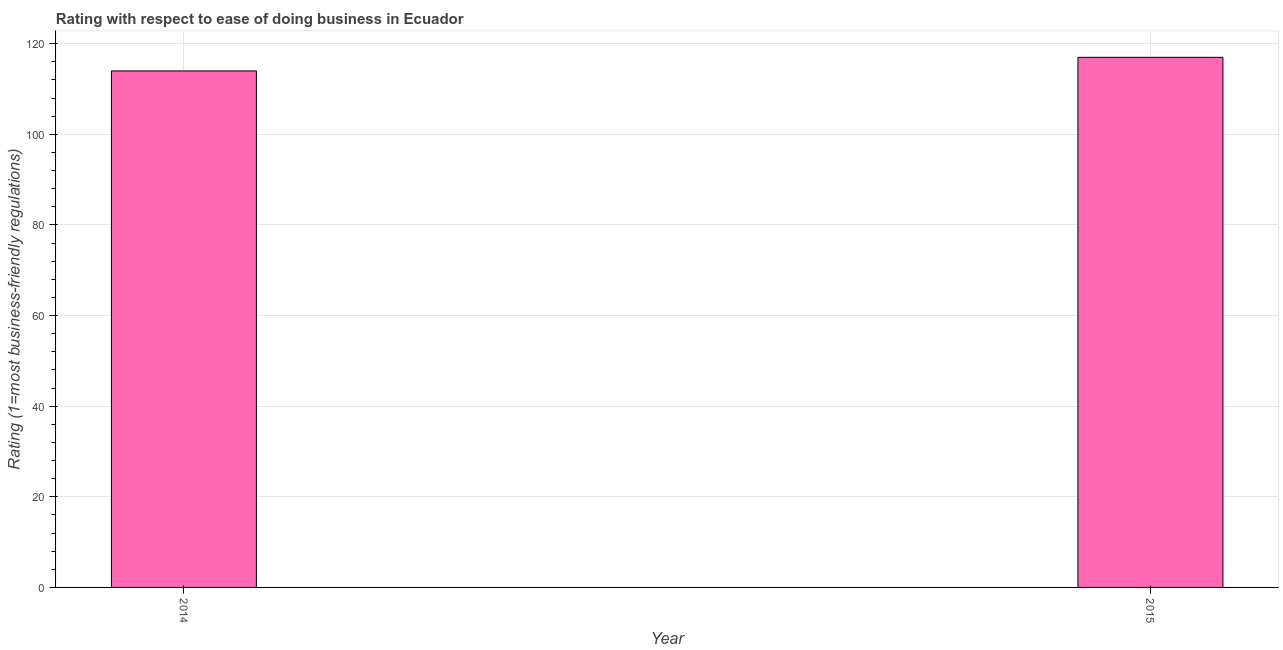Does the graph contain any zero values?
Make the answer very short. No. Does the graph contain grids?
Offer a very short reply. Yes. What is the title of the graph?
Provide a short and direct response. Rating with respect to ease of doing business in Ecuador. What is the label or title of the X-axis?
Offer a terse response. Year. What is the label or title of the Y-axis?
Offer a terse response. Rating (1=most business-friendly regulations). What is the ease of doing business index in 2015?
Keep it short and to the point. 117. Across all years, what is the maximum ease of doing business index?
Keep it short and to the point. 117. Across all years, what is the minimum ease of doing business index?
Offer a terse response. 114. In which year was the ease of doing business index maximum?
Your answer should be compact. 2015. In which year was the ease of doing business index minimum?
Offer a terse response. 2014. What is the sum of the ease of doing business index?
Keep it short and to the point. 231. What is the difference between the ease of doing business index in 2014 and 2015?
Offer a very short reply. -3. What is the average ease of doing business index per year?
Keep it short and to the point. 115. What is the median ease of doing business index?
Provide a short and direct response. 115.5. In how many years, is the ease of doing business index greater than 32 ?
Your answer should be very brief. 2. Do a majority of the years between 2015 and 2014 (inclusive) have ease of doing business index greater than 48 ?
Keep it short and to the point. No. Is the ease of doing business index in 2014 less than that in 2015?
Offer a very short reply. Yes. In how many years, is the ease of doing business index greater than the average ease of doing business index taken over all years?
Keep it short and to the point. 1. How many bars are there?
Provide a succinct answer. 2. How many years are there in the graph?
Give a very brief answer. 2. Are the values on the major ticks of Y-axis written in scientific E-notation?
Give a very brief answer. No. What is the Rating (1=most business-friendly regulations) of 2014?
Your answer should be very brief. 114. What is the Rating (1=most business-friendly regulations) in 2015?
Your response must be concise. 117. What is the difference between the Rating (1=most business-friendly regulations) in 2014 and 2015?
Offer a very short reply. -3. What is the ratio of the Rating (1=most business-friendly regulations) in 2014 to that in 2015?
Keep it short and to the point. 0.97. 